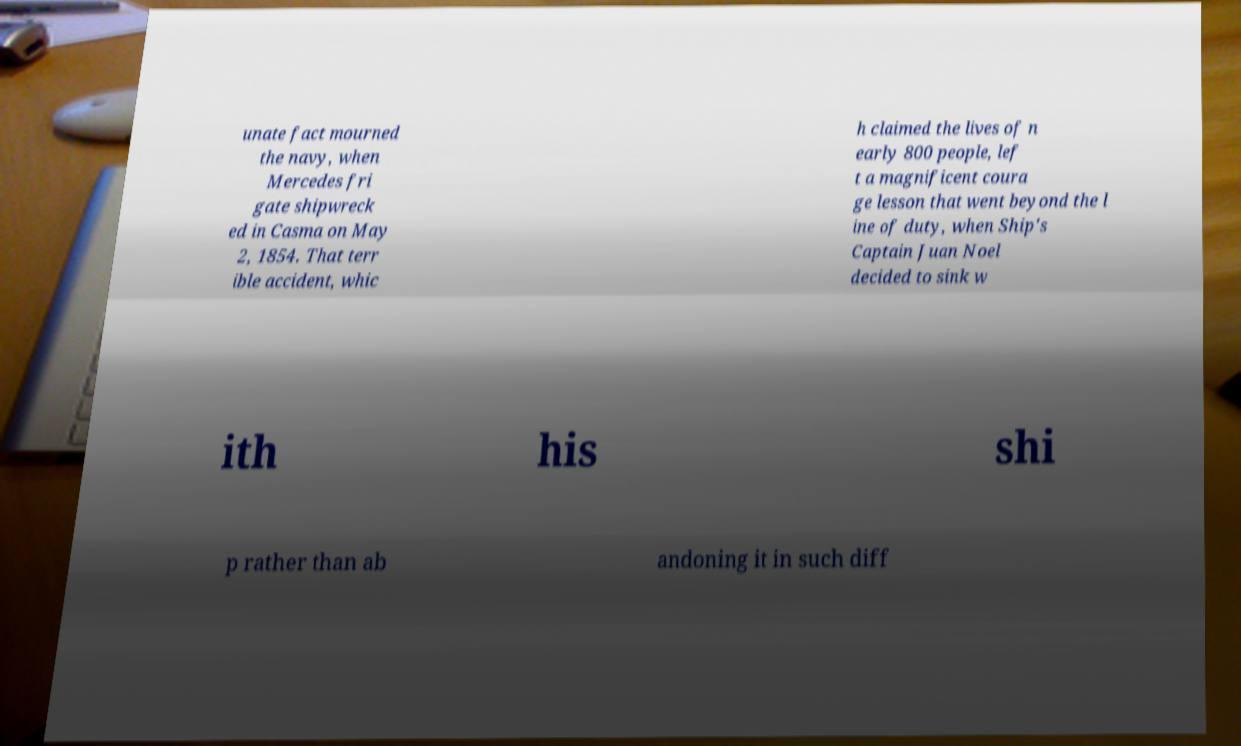What messages or text are displayed in this image? I need them in a readable, typed format. unate fact mourned the navy, when Mercedes fri gate shipwreck ed in Casma on May 2, 1854. That terr ible accident, whic h claimed the lives of n early 800 people, lef t a magnificent coura ge lesson that went beyond the l ine of duty, when Ship's Captain Juan Noel decided to sink w ith his shi p rather than ab andoning it in such diff 